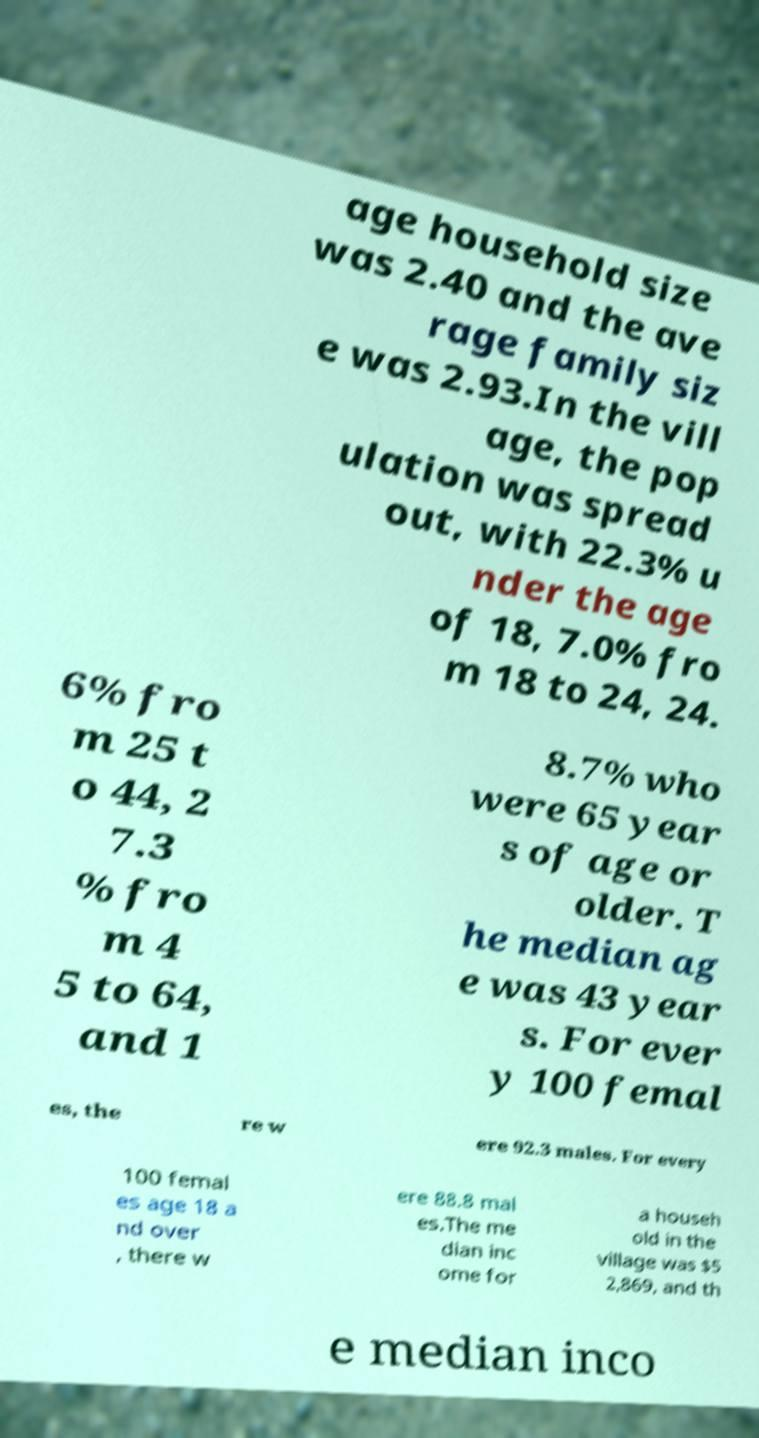There's text embedded in this image that I need extracted. Can you transcribe it verbatim? age household size was 2.40 and the ave rage family siz e was 2.93.In the vill age, the pop ulation was spread out, with 22.3% u nder the age of 18, 7.0% fro m 18 to 24, 24. 6% fro m 25 t o 44, 2 7.3 % fro m 4 5 to 64, and 1 8.7% who were 65 year s of age or older. T he median ag e was 43 year s. For ever y 100 femal es, the re w ere 92.3 males. For every 100 femal es age 18 a nd over , there w ere 88.8 mal es.The me dian inc ome for a househ old in the village was $5 2,869, and th e median inco 